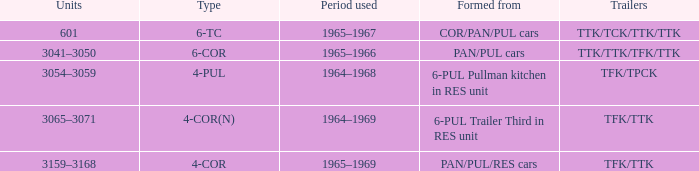What is the figure called that possesses a quadrilateral form? PAN/PUL/RES cars. 